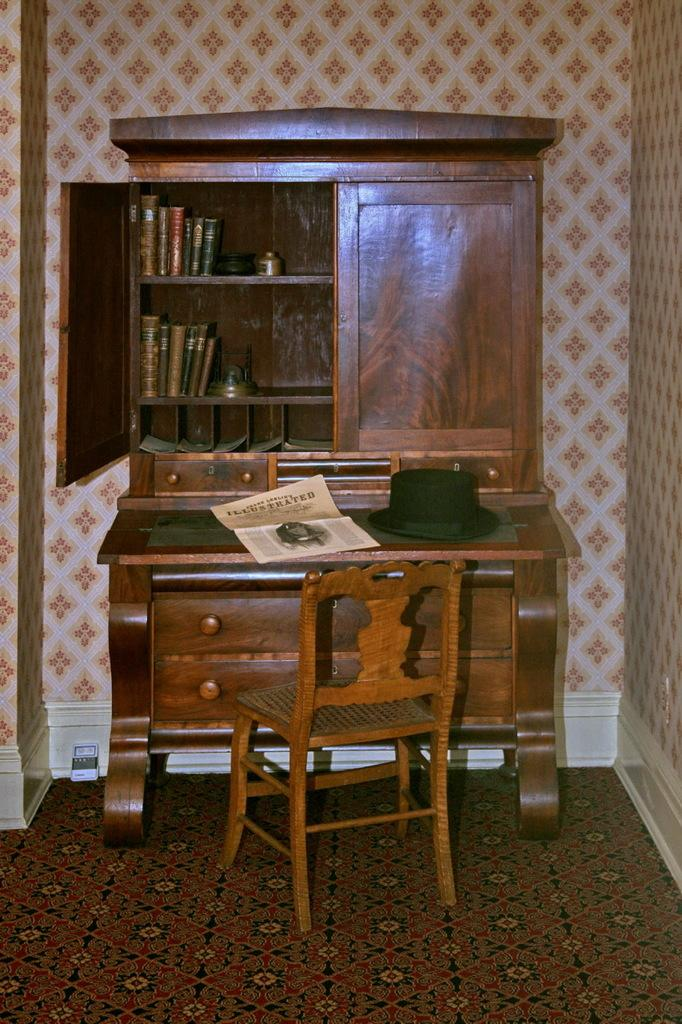What is inside the cupboard in the image? The cupboard is filled with books. What type of accessory is on the cupboard? There is a hat on the cupboard. What else is on the cupboard besides the hat? There is paper on the cupboard. What type of furniture is present in the image? There is a chair in the image. How many beggars are visible in the image? There are no beggars present in the image. What type of ticket is required to enter the room in the image? There is no ticket required to enter the room in the image, as it is a still image and not an actual physical location. 